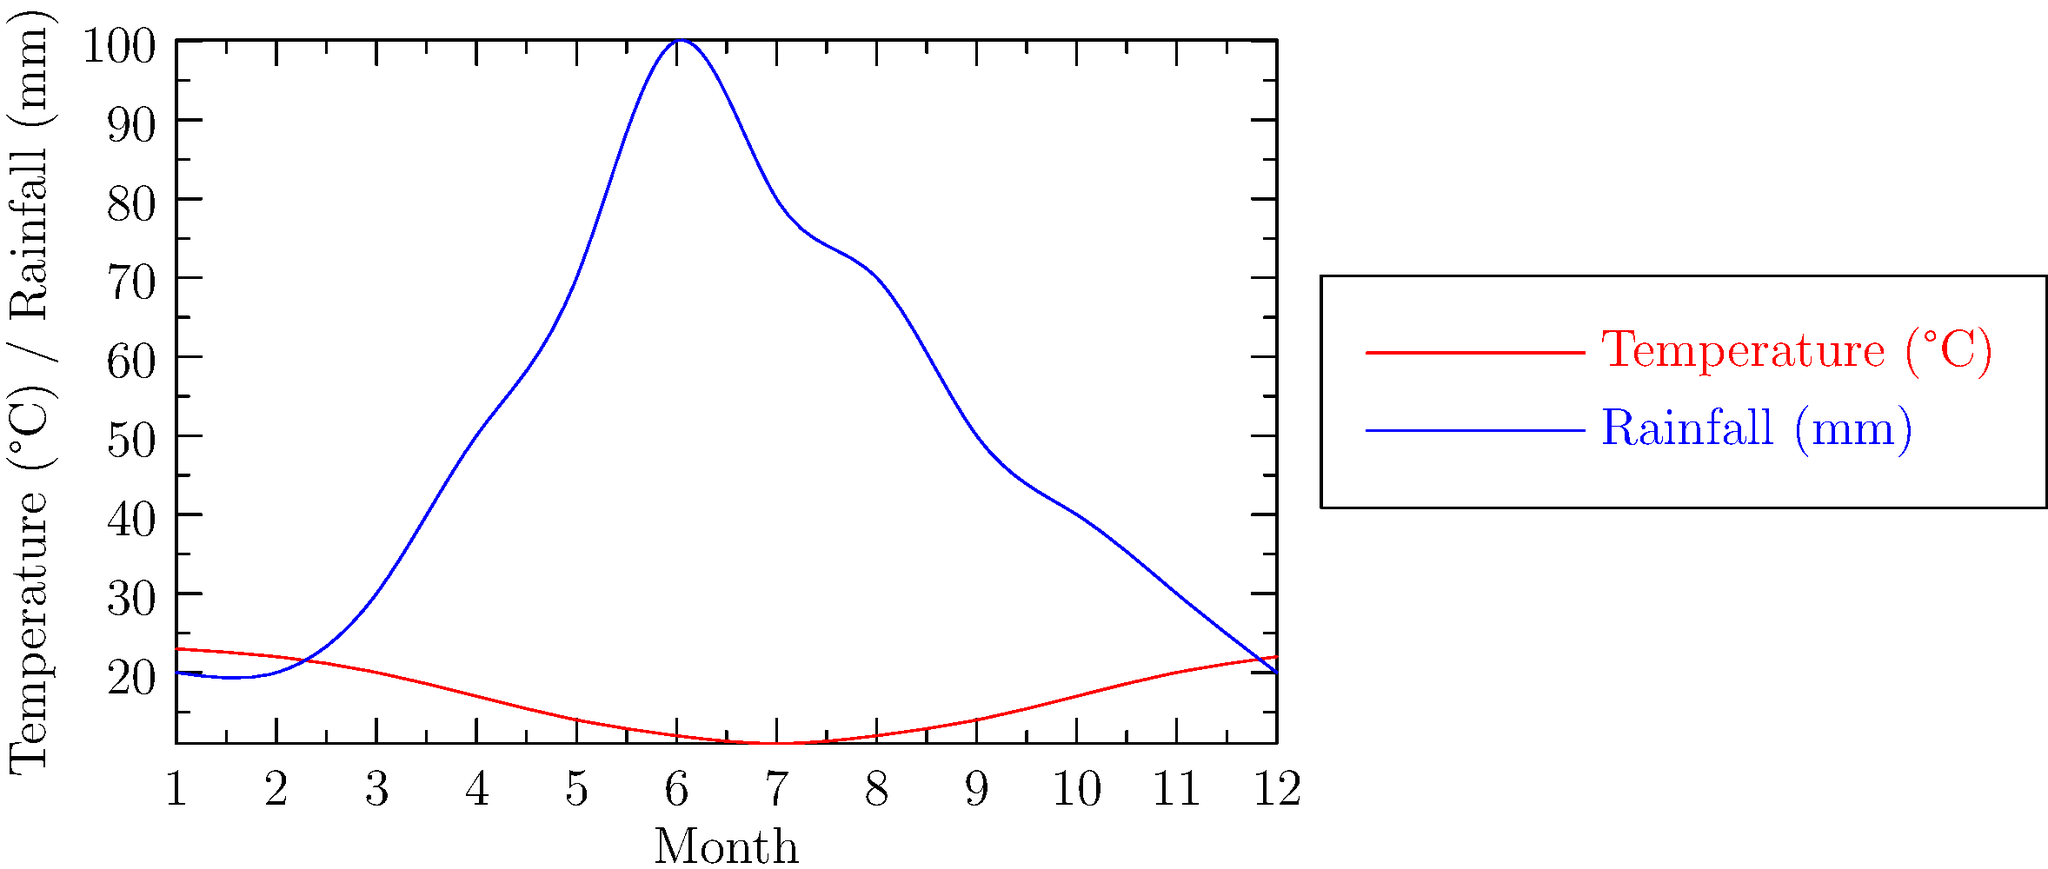Based on the line graph depicting temperature and rainfall patterns in a typical South African wine-growing region, which month appears to be the most suitable for grape harvesting, considering the balance between temperature and rainfall? To determine the most suitable month for grape harvesting in South Africa, we need to consider both temperature and rainfall:

1. Ideal grape harvesting conditions typically require:
   - Warm temperatures (but not extremely hot)
   - Low rainfall to prevent grape dilution and fungal diseases

2. Analyzing the graph:
   - Temperature (red line) peaks in January (month 1) and February (month 2) at around 23°C.
   - Rainfall (blue line) is lowest from December to February (months 12, 1, and 2).

3. Month-by-month assessment:
   - December (month 12): Warm (22°C) with low rainfall (20mm)
   - January (month 1): Warmest (23°C) with lowest rainfall (20mm)
   - February (month 2): Very warm (22°C) with low rainfall (20mm)

4. Conclusion:
   January (month 1) offers the best balance of warm temperature and low rainfall, making it the most suitable for grape harvesting.
Answer: January 